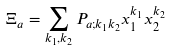Convert formula to latex. <formula><loc_0><loc_0><loc_500><loc_500>\Xi _ { a } = \sum _ { k _ { 1 } , k _ { 2 } } P _ { a ; k _ { 1 } k _ { 2 } } x _ { 1 } ^ { k _ { 1 } } x _ { 2 } ^ { k _ { 2 } }</formula> 